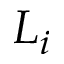<formula> <loc_0><loc_0><loc_500><loc_500>L _ { i }</formula> 